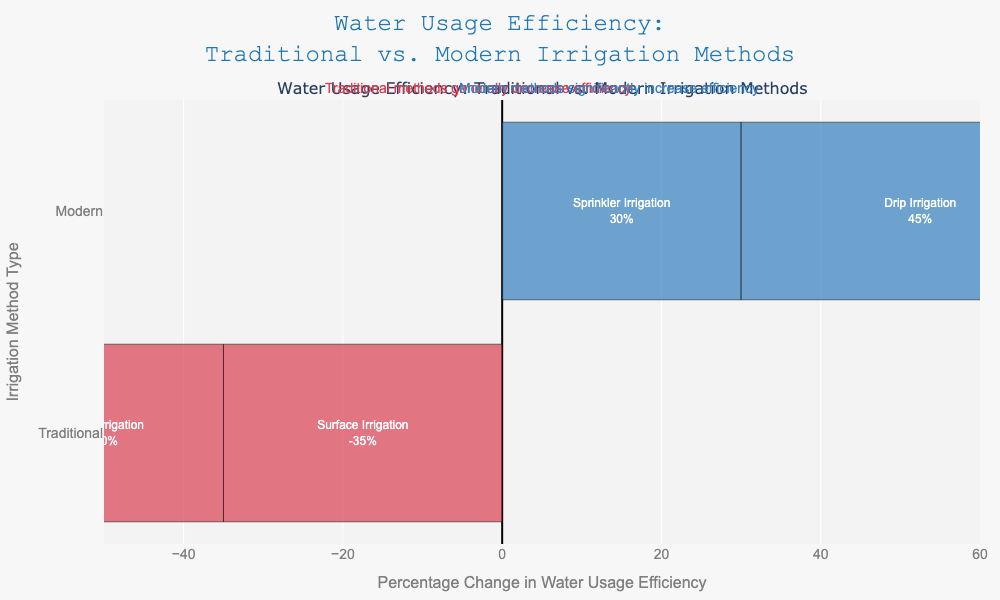What is the irrigation method with the highest increase in water usage efficiency? To find the highest increase in water usage efficiency, we look at the positive values on the plot. The bar corresponding to Subsurface Drip Irrigation indicates the highest increase at 50%.
Answer: Subsurface Drip Irrigation Which traditional irrigation method shows the lowest water usage efficiency? To determine the traditional method with the lowest efficiency, check the negative values specifically among traditional methods. The bar for Surface Irrigation shows the lowest efficiency at -35%.
Answer: Surface Irrigation What is the difference in water usage efficiency between Drip Irrigation and Furrow Irrigation? Drip Irrigation has an efficiency increase of 45%, while Furrow Irrigation shows a decrease of -25%. Calculating the difference: 45 - (-25) = 45 + 25 = 70.
Answer: 70 How do the modern irrigation methods compare in terms of water usage efficiency? Comparing the positive values, Drip Irrigation increases efficiency by 45%, Sprinkler Irrigation by 30%, and Subsurface Drip Irrigation by 50%. The efficiencies are ordered as Subsurface Drip Irrigation > Drip Irrigation > Sprinkler Irrigation.
Answer: Subsurface Drip Irrigation > Drip Irrigation > Sprinkler Irrigation Which traditional irrigation method has the least negative impact on water usage efficiency? Among traditional methods with negative values, Furrow Irrigation has the least negative impact at -25%.
Answer: Furrow Irrigation What is the overall range of percentage change in water usage efficiency across all methods? Examine the minimum and maximum changes in percentage efficiency. The minimum is -35% (Surface Irrigation) and the maximum is 50% (Subsurface Drip Irrigation). The range is 50 - (-35) = 50 + 35 = 85.
Answer: 85 How much more efficient is the most efficient modern method compared to the least efficient traditional method? The most efficient modern method is Subsurface Drip Irrigation (50%) and the least efficient traditional method is Surface Irrigation (-35%). The difference is 50 - (-35) = 50 + 35 = 85.
Answer: 85 What is the average change in water usage efficiency for traditional irrigation methods? Adding up the efficiencies for traditional methods: -30 + (-25) + (-35) = -90. There are three methods, so the average is -90/3 = -30.
Answer: -30 